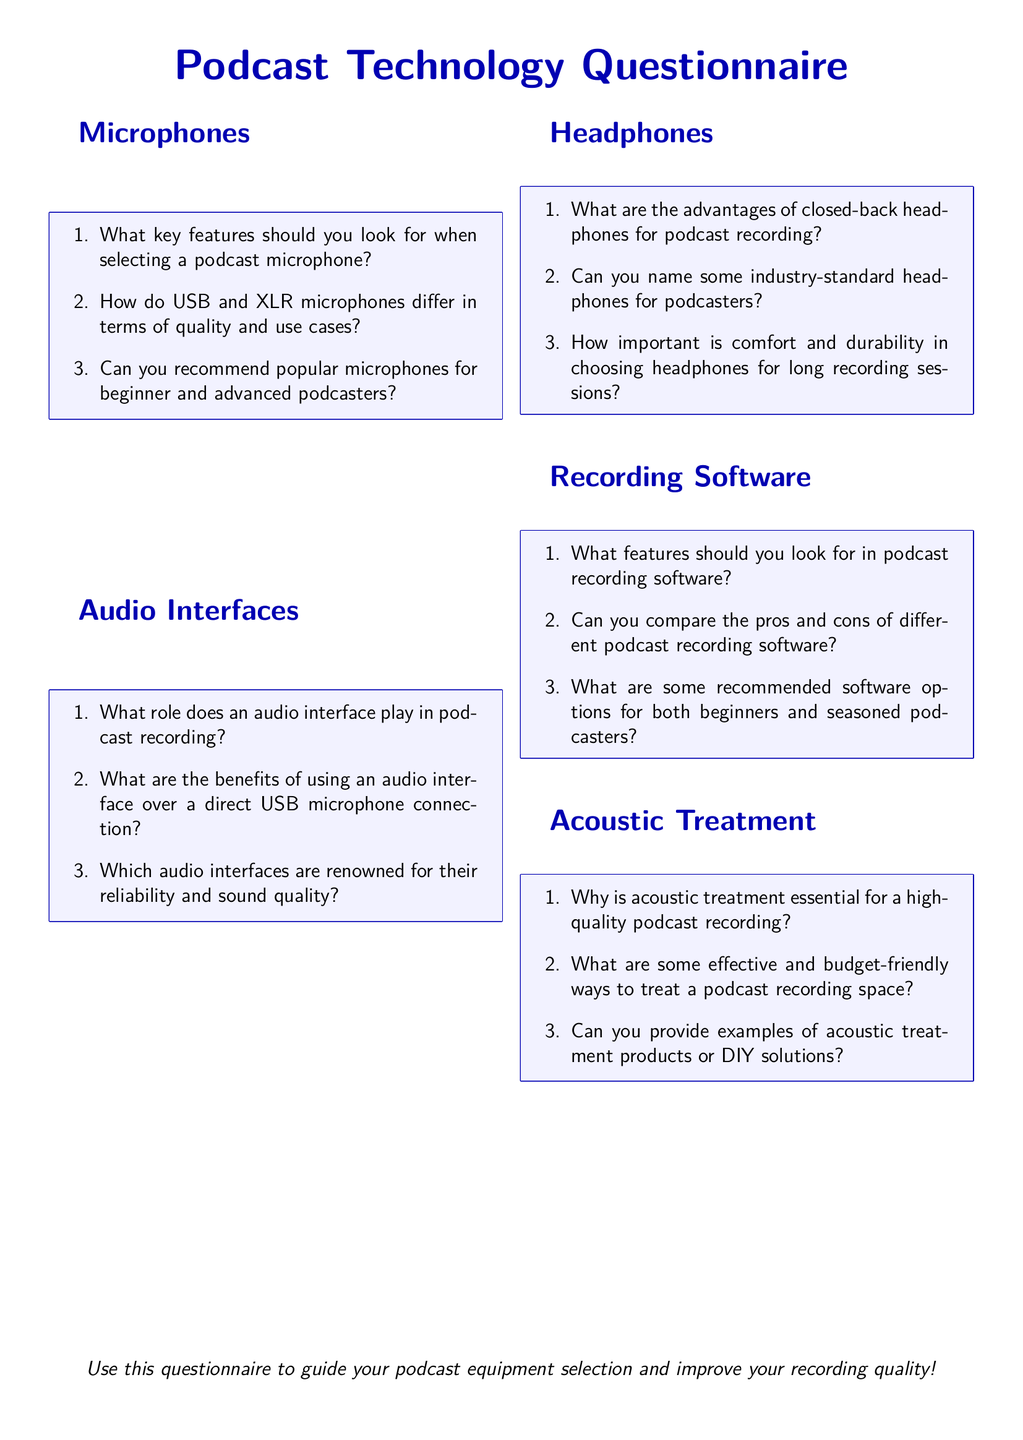What key features should you look for when selecting a podcast microphone? This question asks for specific information listed under the microphone section in the questionnaire.
Answer: Key features How do USB and XLR microphones differ in terms of quality and use cases? This question requires understanding the comparative aspects of USB and XLR microphones mentioned in the document.
Answer: Quality and use cases What are some recommended software options for both beginners and seasoned podcasters? This question seeks specific software recommendations that can be found in the recording software section.
Answer: Recommended software options Why is acoustic treatment essential for a high-quality podcast recording? This question pertains to the importance of acoustic treatment mentioned under the acoustic treatment section of the document.
Answer: Essential for quality What are the advantages of closed-back headphones for podcast recording? This question requests specific advantages concerning closed-back headphones stated in the headphones section.
Answer: Advantages of closed-back headphones Which audio interfaces are renowned for their reliability and sound quality? This seeks the names of audio interfaces noted for their quality and reliability as indicated in the document.
Answer: Renowned audio interfaces 